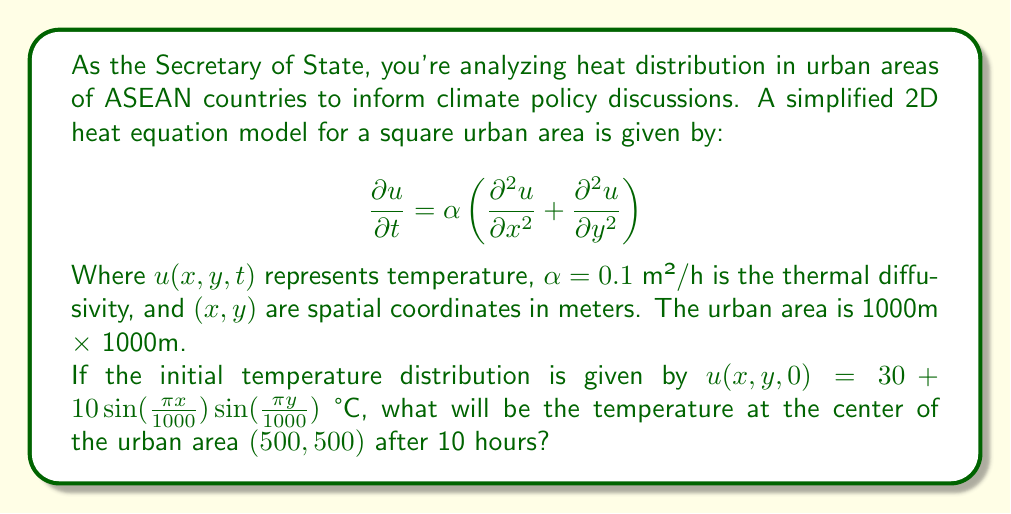Solve this math problem. To solve this problem, we'll follow these steps:

1) The general solution to the 2D heat equation with the given initial condition is:

   $$u(x,y,t) = 30 + 10e^{-2\alpha\pi^2t/L^2}\sin(\frac{\pi x}{L})\sin(\frac{\pi y}{L})$$

   Where $L = 1000$ m is the side length of the square area.

2) We need to evaluate this at $x = 500$ m, $y = 500$ m, and $t = 10$ hours.

3) First, let's calculate the exponent:
   
   $$-2\alpha\pi^2t/L^2 = -2 \cdot 0.1 \cdot \pi^2 \cdot 10 / 1000^2 = -0.000197$$

4) Now, let's evaluate the sine terms:

   $$\sin(\frac{\pi \cdot 500}{1000}) = \sin(\frac{\pi}{2}) = 1$$

   This is the same for both $x$ and $y$.

5) Putting it all together:

   $$u(500,500,10) = 30 + 10e^{-0.000197} \cdot 1 \cdot 1$$

6) Calculate the exponential:

   $$e^{-0.000197} = 0.9998$$

7) Final calculation:

   $$u(500,500,10) = 30 + 10 \cdot 0.9998 = 39.998$$
Answer: 39.998 °C 